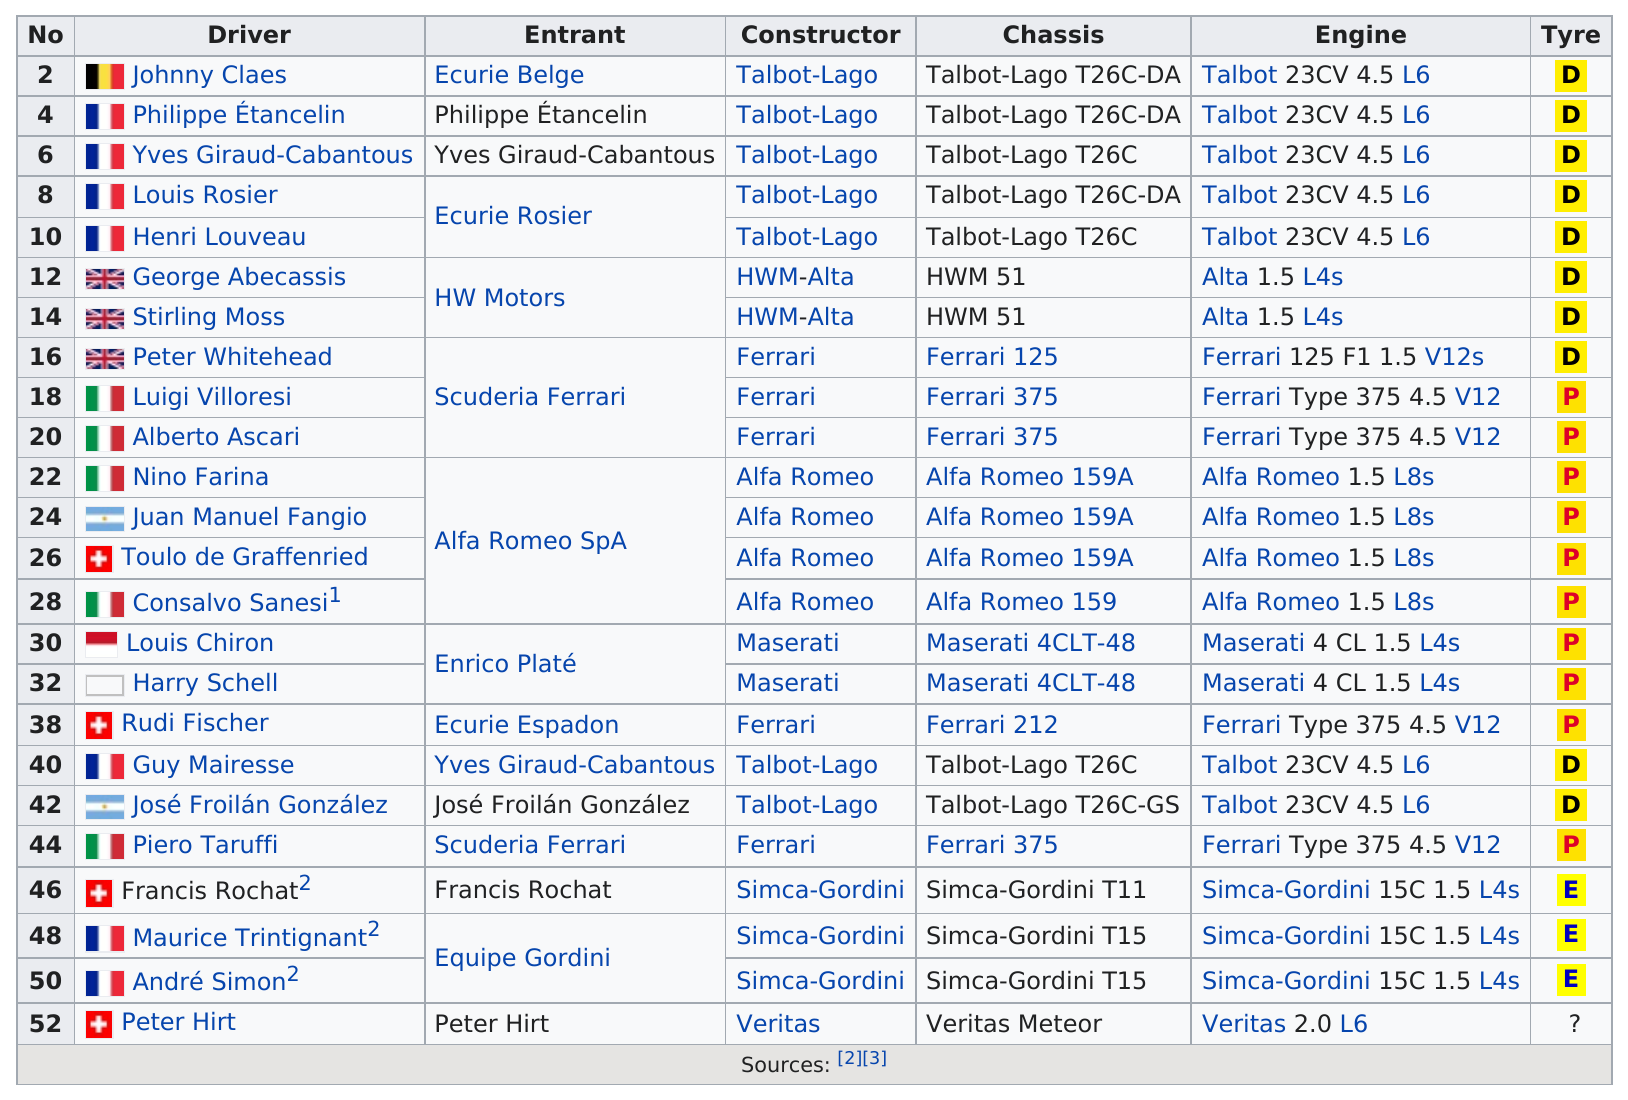Draw attention to some important aspects in this diagram. Johnny Claes precedes Philippe Etancelin in the chart. The Talbot 23CV 4.5 L6 is the first engine listed on the chart. There are fewer than 39 drivers listed on the chart. It is accurate to state that Peter Hirt is the only person who has driven a Veritas car. France has four consecutive drivers on their roster. 